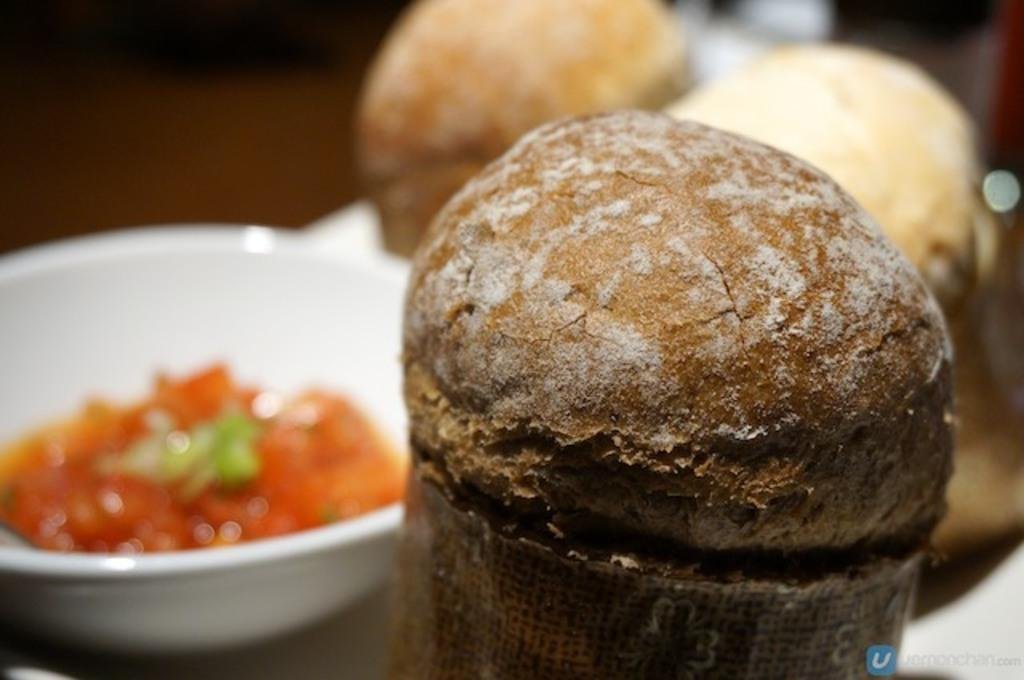What is present on the table in the image? There is food placed on the table in the image. Can you describe the bowl on the left side of the table? There is a white color bowl on the left side of the table. What can be observed about the background of the image? The background of the image is blurred. What type of plastic material is used to make the jelly in the image? There is no jelly present in the image, so it is not possible to determine the type of plastic material used. 